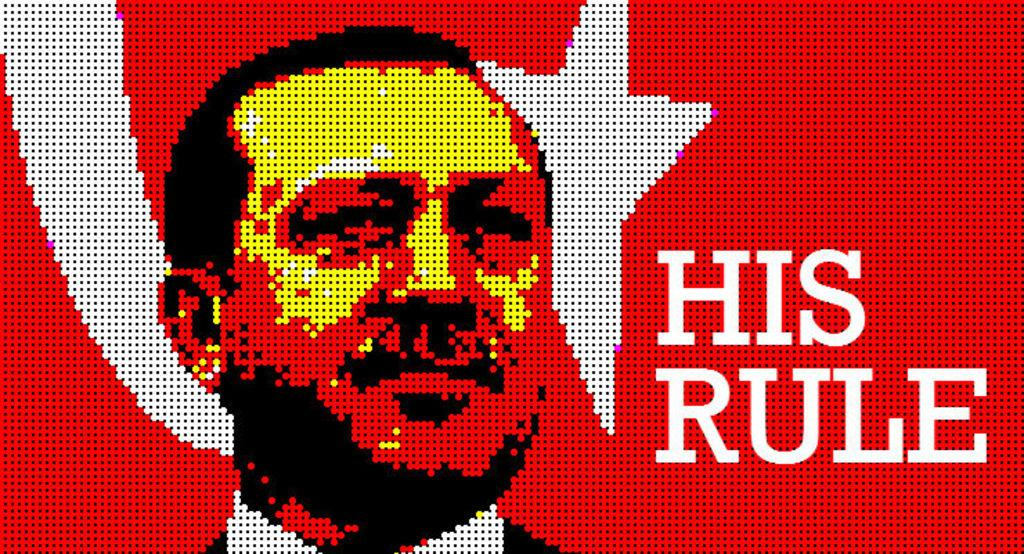<image>
Describe the image concisely. A pixelated image has the phrase "his rule" on it. 